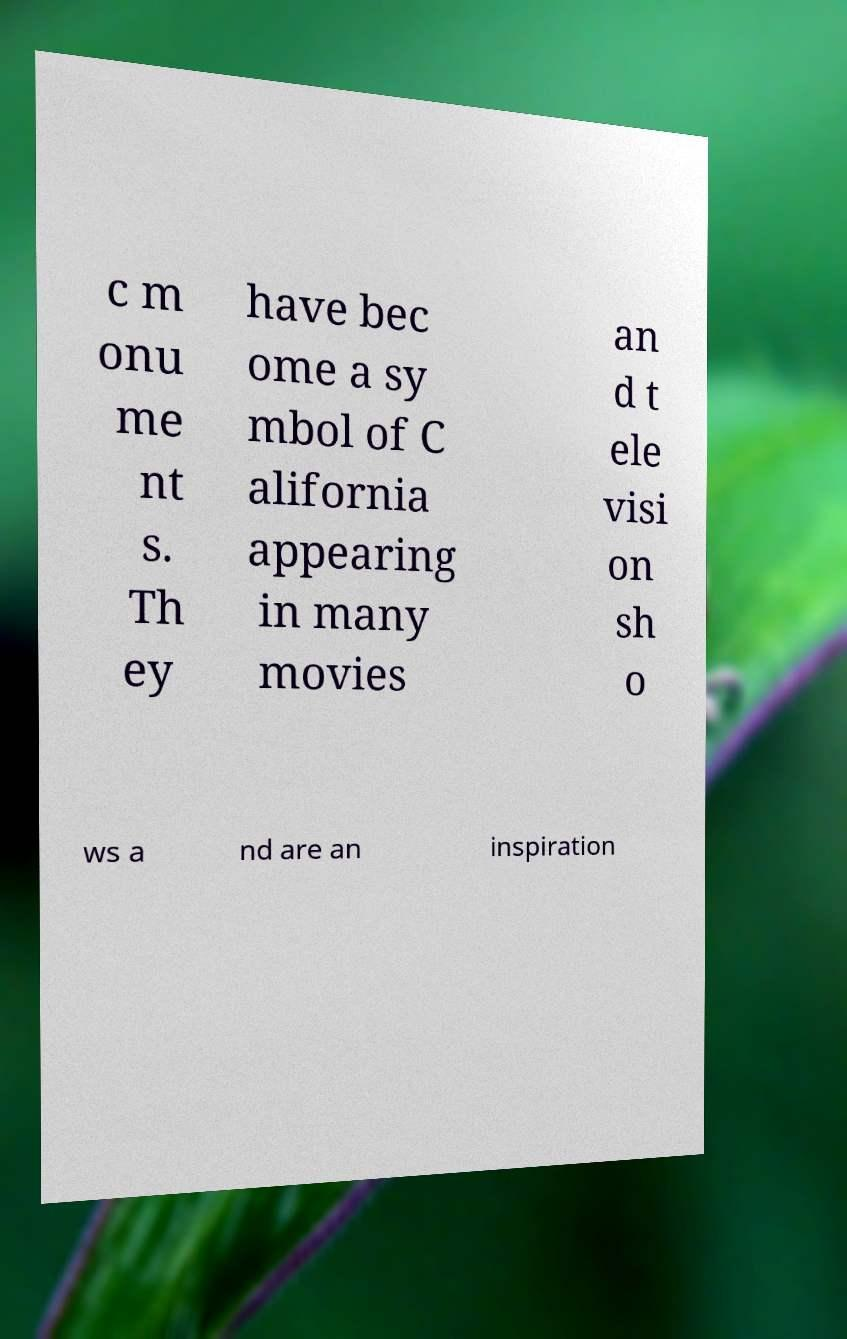Please identify and transcribe the text found in this image. c m onu me nt s. Th ey have bec ome a sy mbol of C alifornia appearing in many movies an d t ele visi on sh o ws a nd are an inspiration 